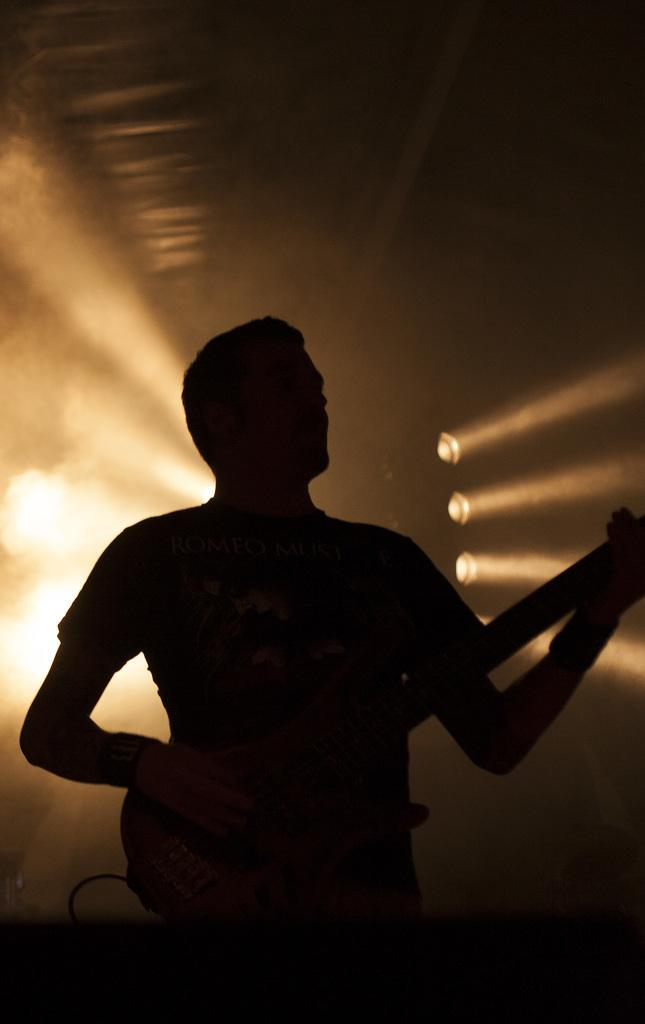What is the man in the image holding? The man is holding a guitar. What can be seen behind the man in the image? There are lights visible behind the man. What type of thread is being used to decorate the holiday tree in the image? There is no holiday tree or thread present in the image; it features a man holding a guitar with lights visible behind him. 